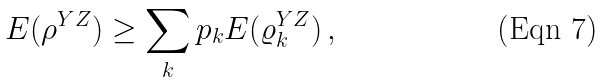Convert formula to latex. <formula><loc_0><loc_0><loc_500><loc_500>E ( \rho ^ { Y Z } ) \geq \sum _ { k } p _ { k } E ( \varrho _ { k } ^ { Y Z } ) \, ,</formula> 